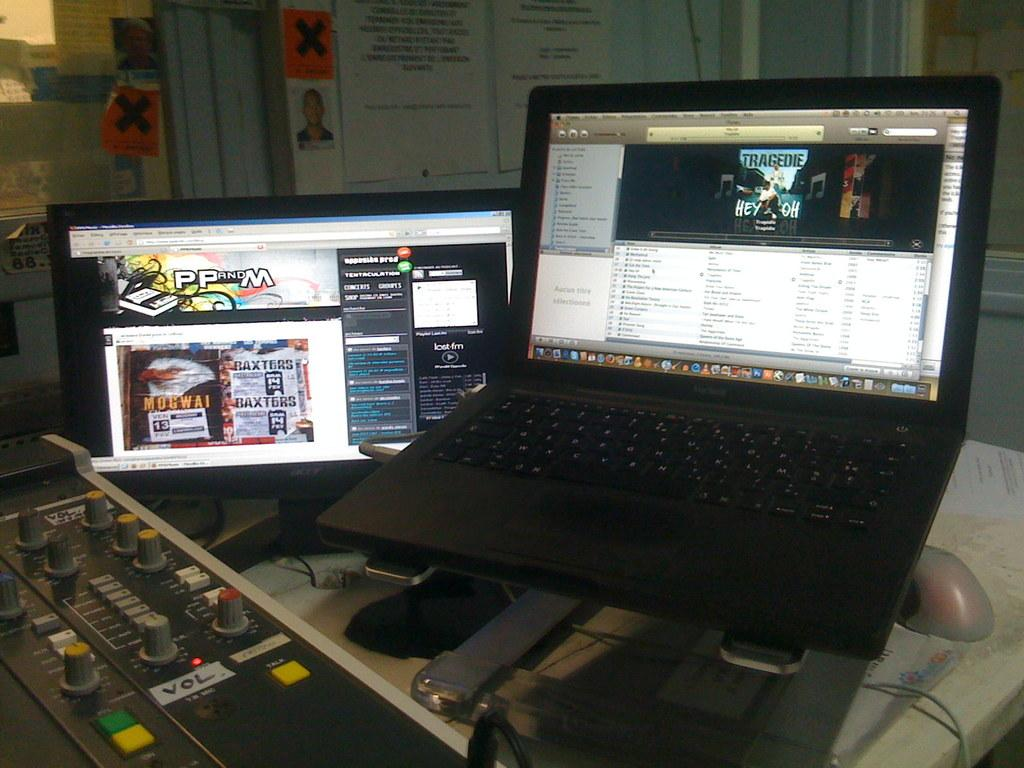<image>
Relay a brief, clear account of the picture shown. Black laptop with a screen showing "tragedie Hey Oh" on it. 